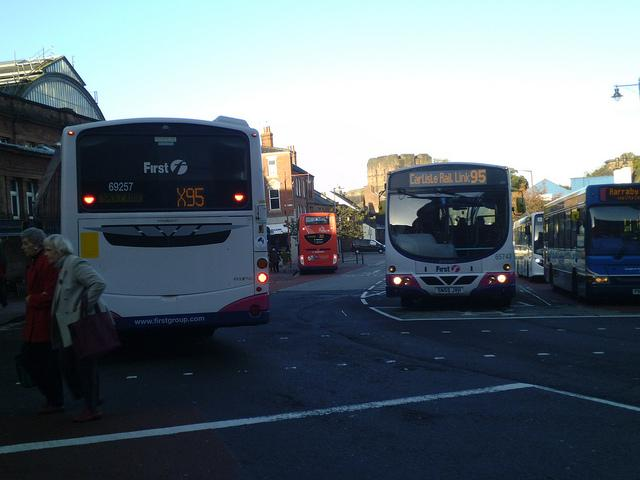In which area do these buses run? Please explain your reasoning. urban. It's common knowledge that buses run in almost every urban center. 